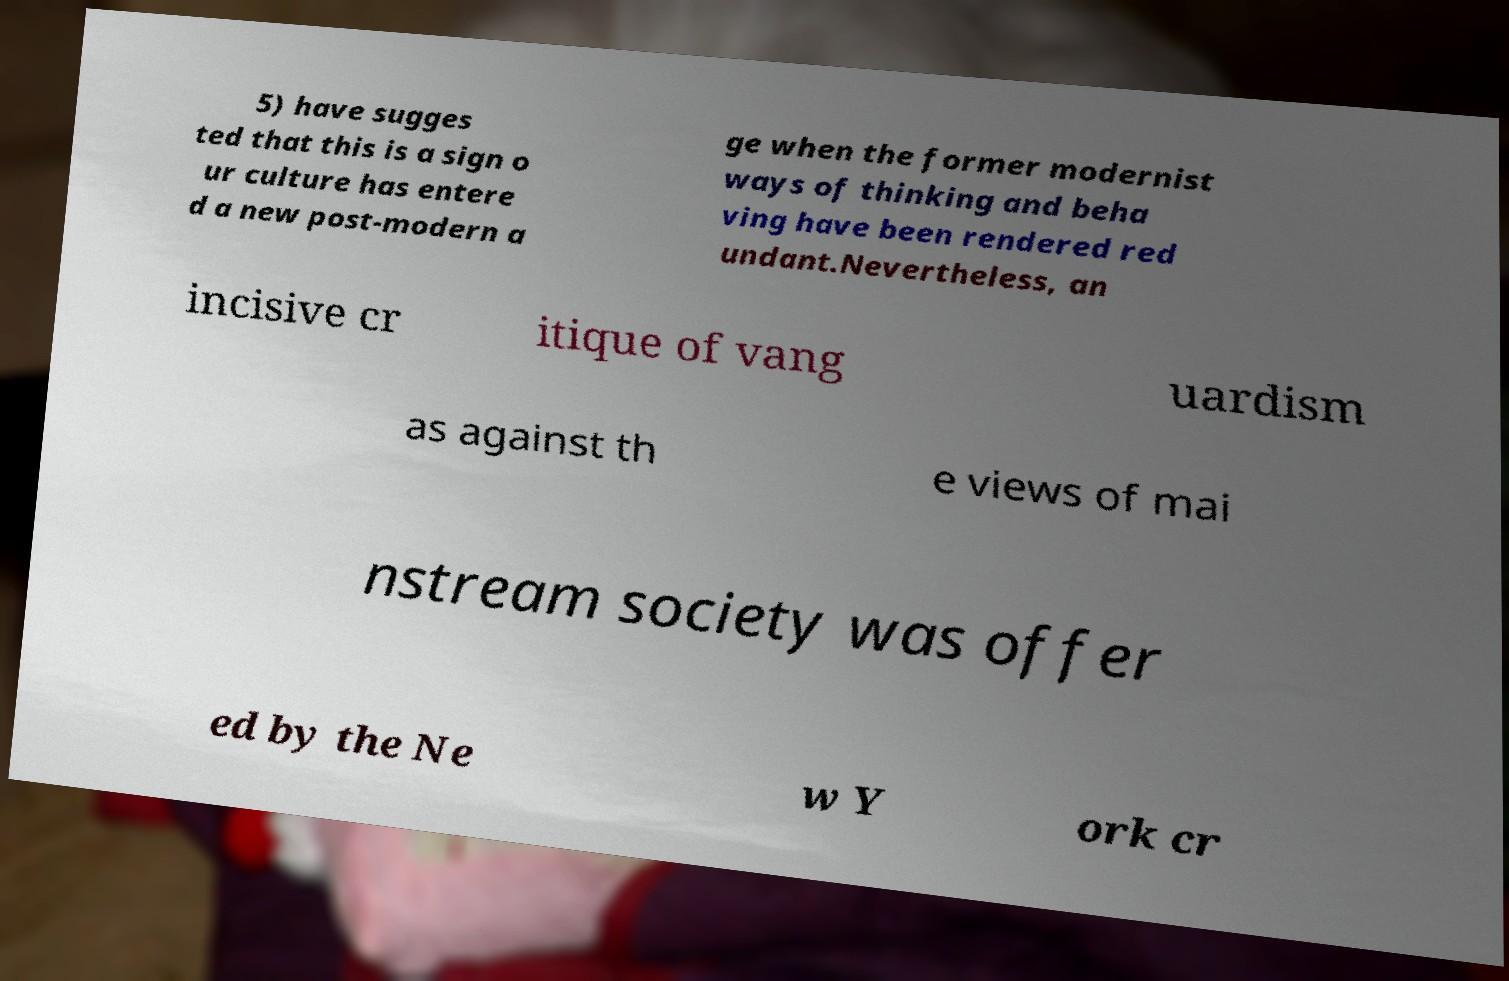Can you read and provide the text displayed in the image?This photo seems to have some interesting text. Can you extract and type it out for me? 5) have sugges ted that this is a sign o ur culture has entere d a new post-modern a ge when the former modernist ways of thinking and beha ving have been rendered red undant.Nevertheless, an incisive cr itique of vang uardism as against th e views of mai nstream society was offer ed by the Ne w Y ork cr 